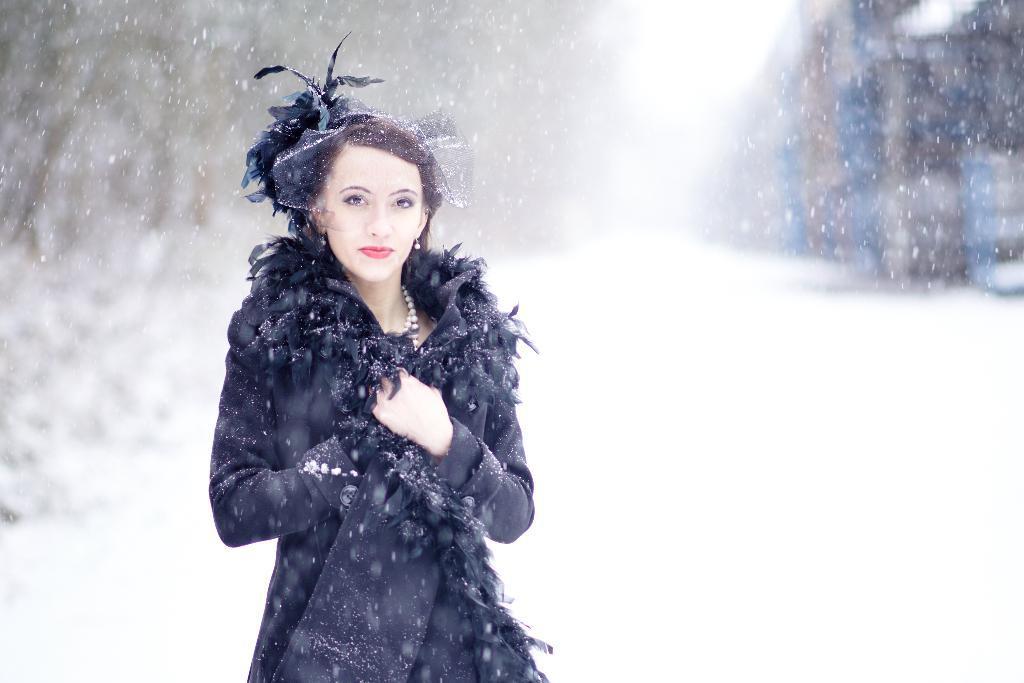In one or two sentences, can you explain what this image depicts? A woman is standing on the left wearing a black dress, pearls chain and there are hairs on her head. There is a snowfall and the background is blurred. 